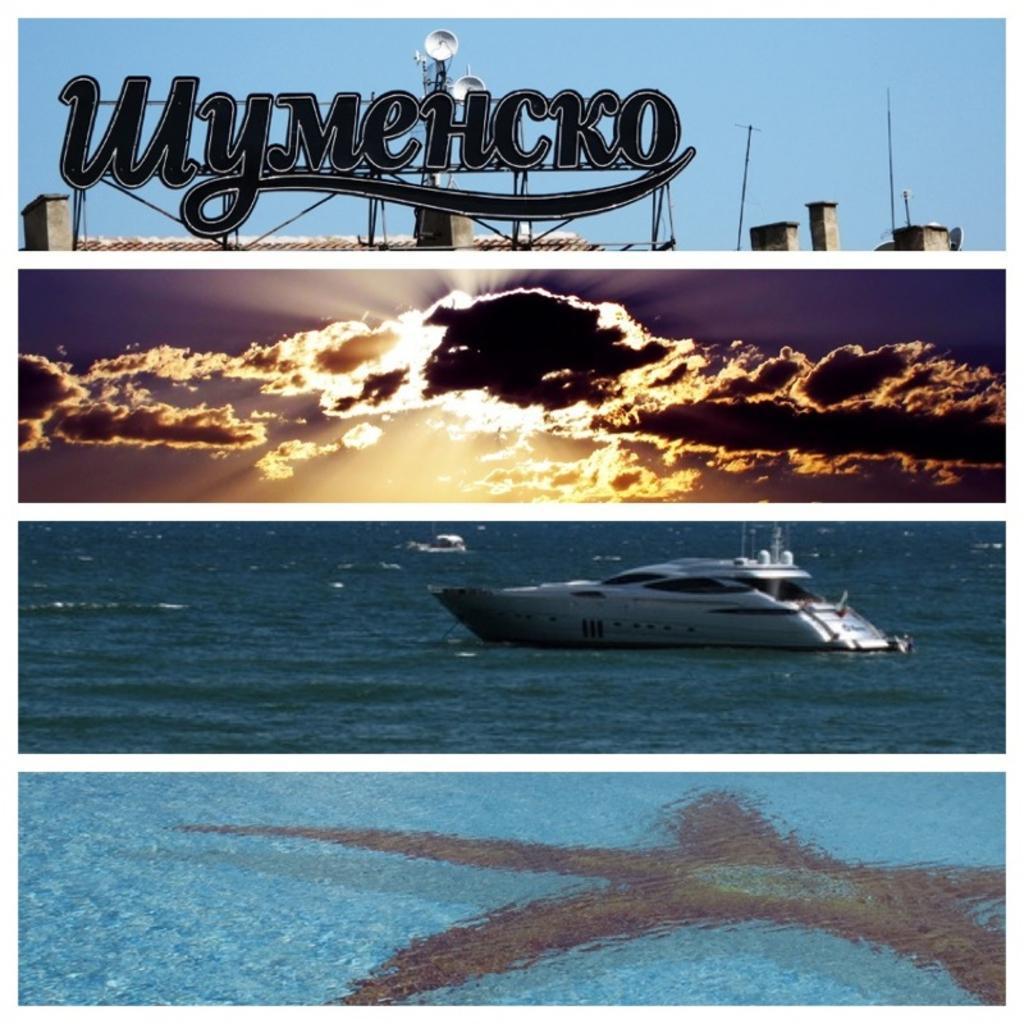Describe this image in one or two sentences. In the image we can see the collage photos. On the top image we can see the text, poles and the sky. In the second image we can see the cloudy sky. In the third image we can see the boat in the water and in the fourth image we can see the water. 